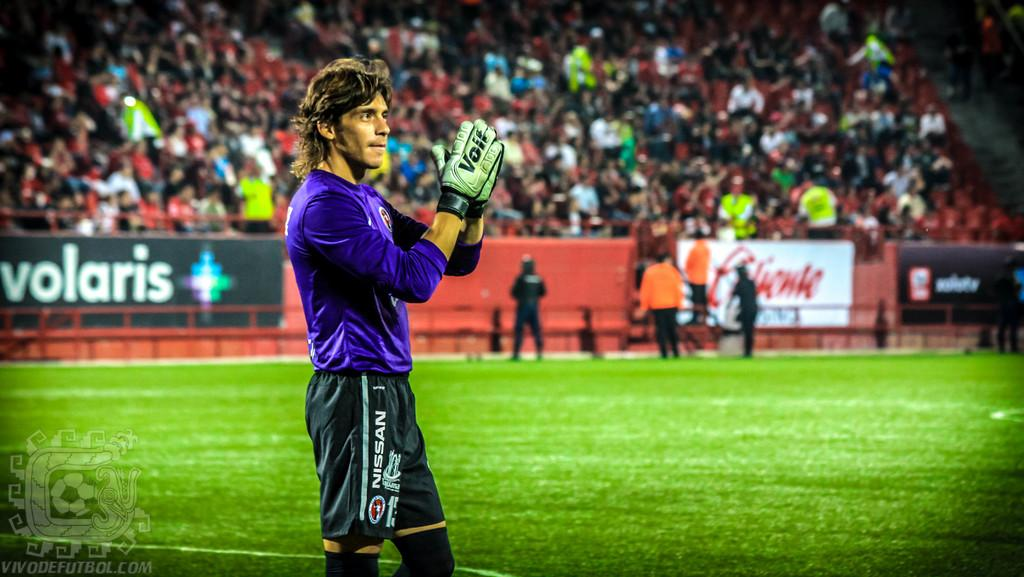What is the main subject of the image? There is a sportsman standing in the center of the image. What can be seen in the background of the image? There is a crowd sitting in the background, and there are people visible in the background. What type of surface is at the bottom of the image? There is grass at the bottom of the image. What objects can be seen in the image besides the sportsman and the crowd? There are boards visible in the image. Can you tell me what type of locket the baby is wearing in the image? There is no baby or locket present in the image. 